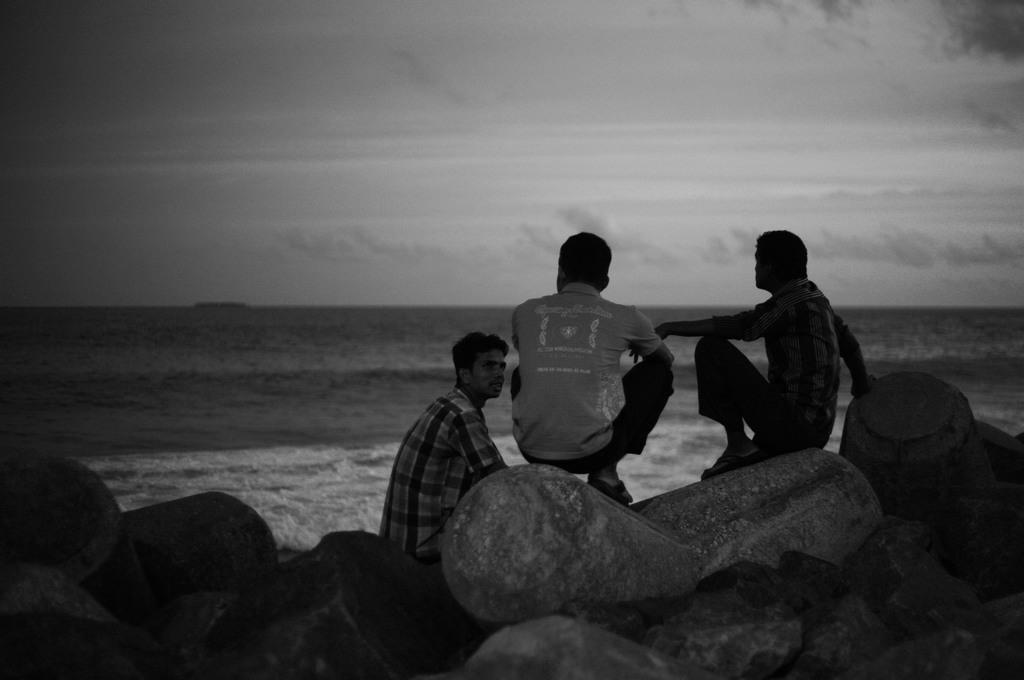How many people are in the image? There are three people in the image. What are the people doing in the image? The people are sitting on rocks. What can be seen in the background of the image? There is water visible in the image, as well as clouds. What type of shade does the cub prefer in the image? There is no cub present in the image, so it is not possible to determine its preferences. 